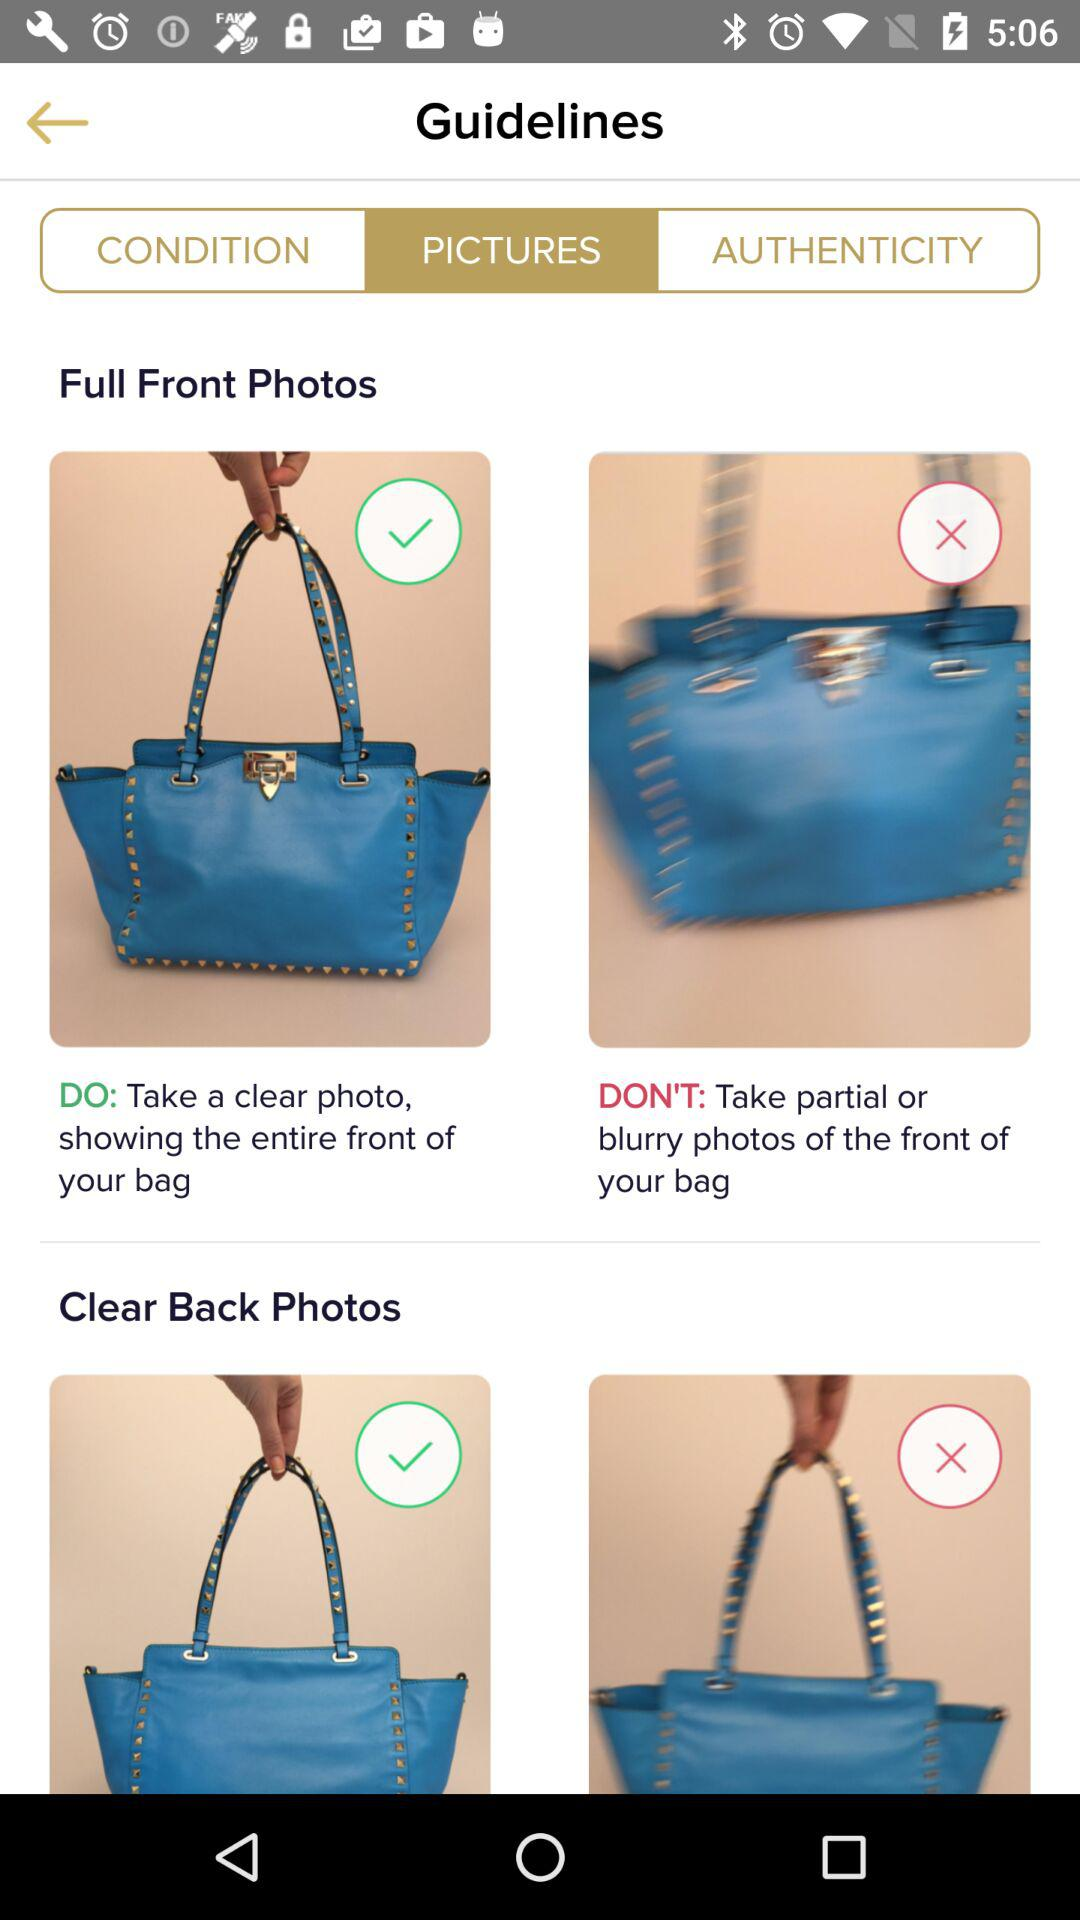What is the description given in the DO's section? The description given in the DO's section is "Take a clear photo, showing the entire front of your bag". 